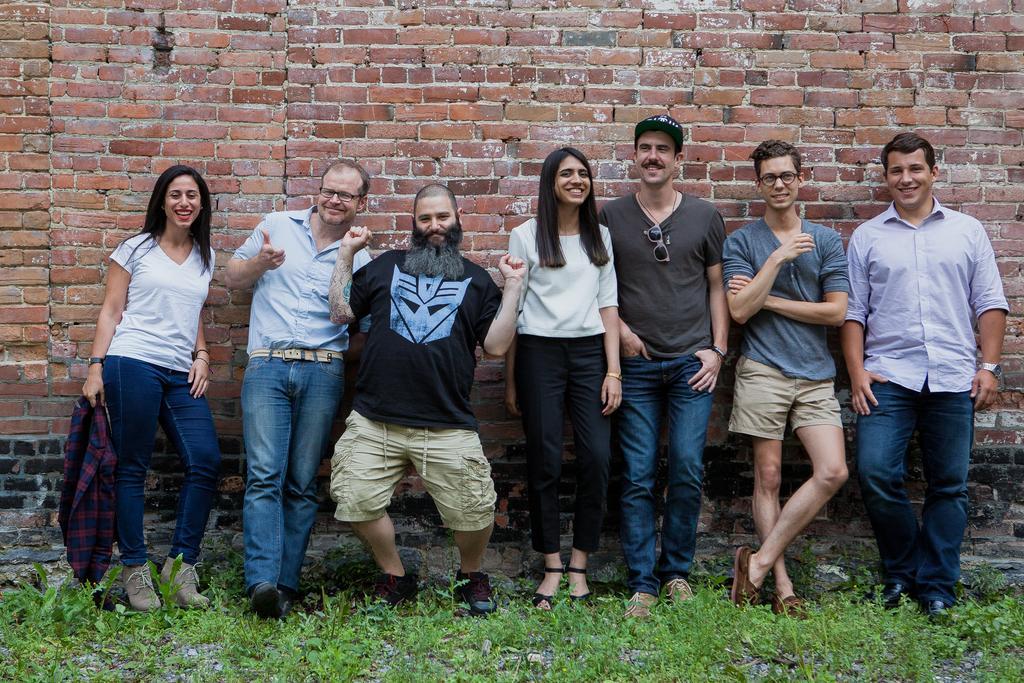Can you describe this image briefly? In this picture we can see a group of people standing on the ground and smiling, grass and in the background we can see wall. 